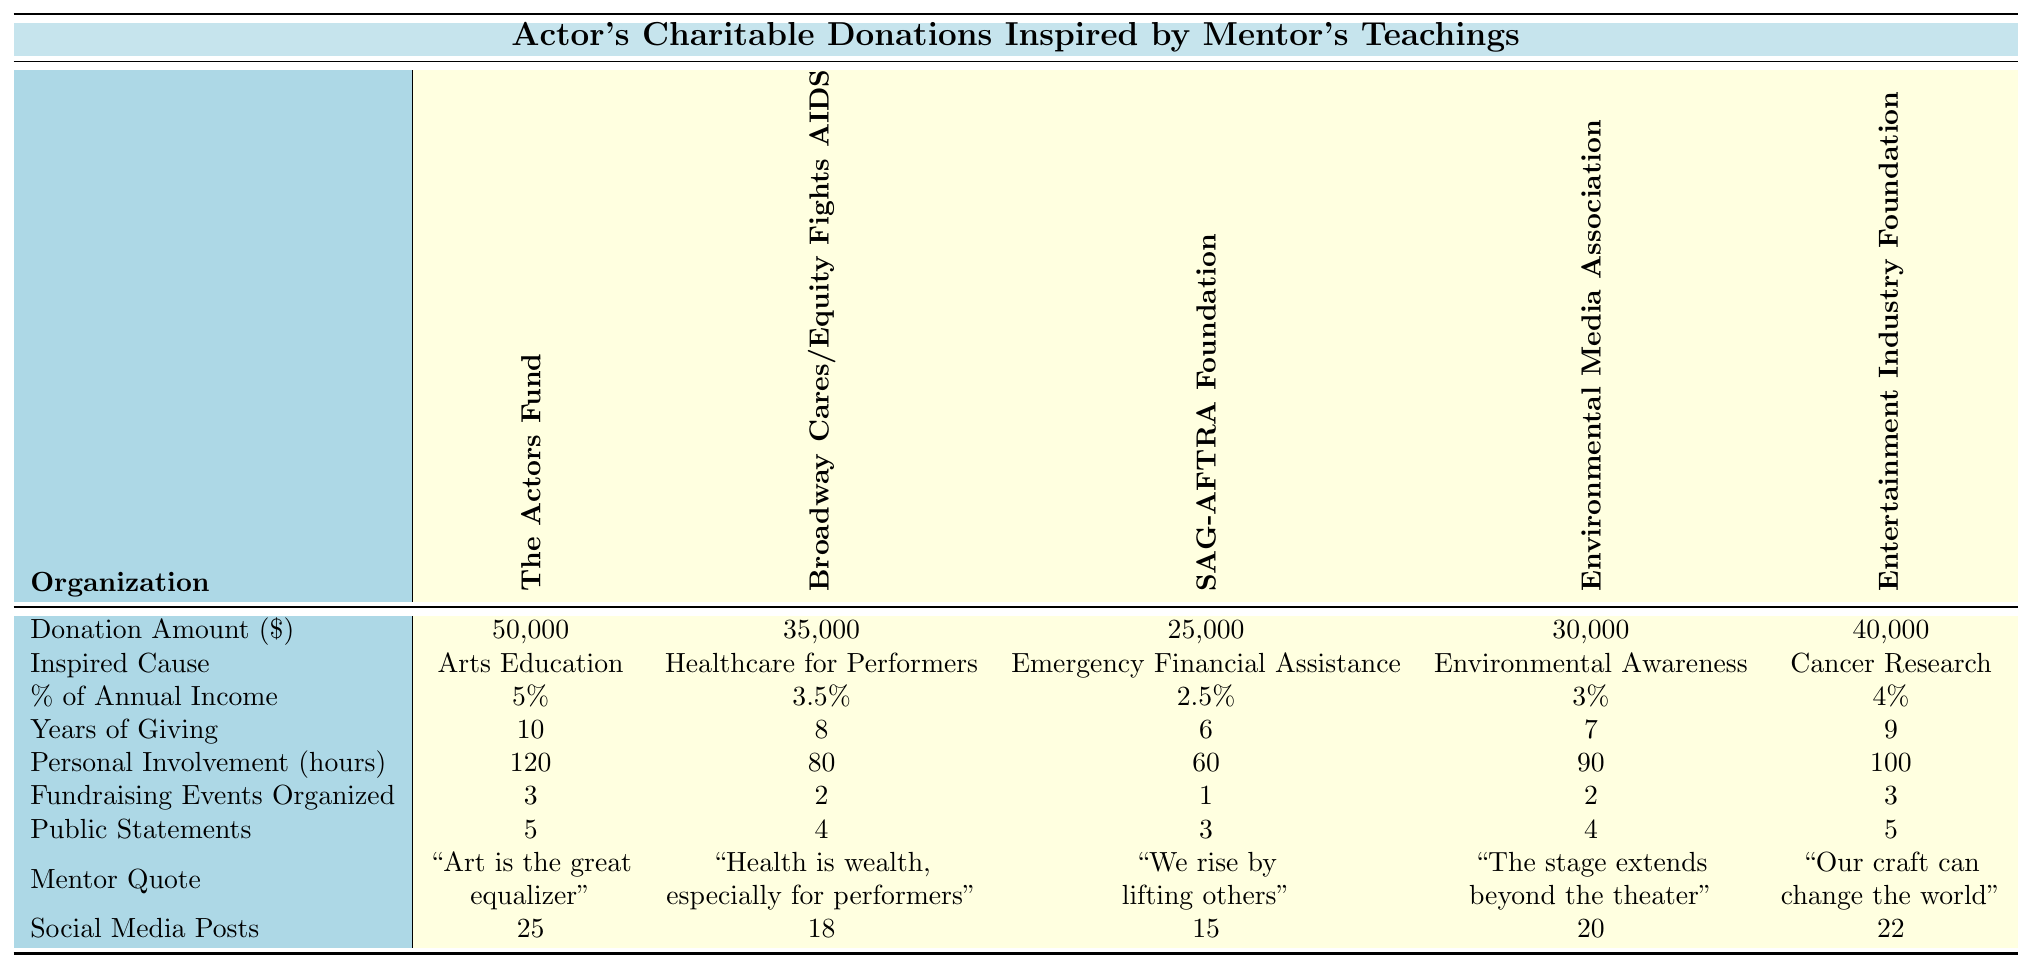What is the total donation amount to all charitable organizations listed? To find the total donation amount, we sum the individual donation amounts: 50,000 + 35,000 + 25,000 + 30,000 + 40,000 = 180,000.
Answer: 180,000 Which charitable organization received the least amount of donation? By comparing the donation amounts listed, SAG-AFTRA Foundation received the least with 25,000.
Answer: SAG-AFTRA Foundation How many years has the actor given to the organization "The Actors Fund"? The table states that the actor has given to "The Actors Fund" for 10 years.
Answer: 10 years What is the average percentage of annual income donated across all organizations? To calculate the average, sum the percentages (5 + 3.5 + 2.5 + 3 + 4) = 18 and divide by the number of organizations (5): 18/5 = 3.6.
Answer: 3.6% Did the actor organize more than 2 fundraising events for the Environmental Media Association? The table shows that the actor organized 2 fundraising events for the Environmental Media Association, which is not more than 2.
Answer: No What is the total amount of personal involvement hours dedicated to the listed organizations? The total personal involvement hours are calculated by summing: 120 + 80 + 60 + 90 + 100 = 450 hours.
Answer: 450 hours Which cause inspired the highest donation amount? The "The Actors Fund" received the highest donation amount of 50,000, which corresponds to the inspired cause of Arts Education.
Answer: Arts Education What is the average number of public statements made about the causes supported by the actor? Summing the public statements (5 + 4 + 3 + 4 + 5) gives 21, and dividing by 5 organizations yields an average of 21/5 = 4.2.
Answer: 4.2 How many causes have a donation percentage greater than 3%? The organizations with percentages over 3% are "The Actors Fund" (5%), "Broadway Cares/Equity Fights AIDS" (3.5%), and "Entertainment Industry Foundation" (4%). This totals 3 causes.
Answer: 3 causes What is the donation amount for the cause related to Environmental Awareness? The table states that the donation amount for "Environmental Media Association," which pertains to Environmental Awareness, is 30,000.
Answer: 30,000 What percentage of the actor's annual income is represented by donations to the SAG-AFTRA Foundation? The table indicates that donations to the SAG-AFTRA Foundation represent 2.5% of the actor's annual income.
Answer: 2.5% 